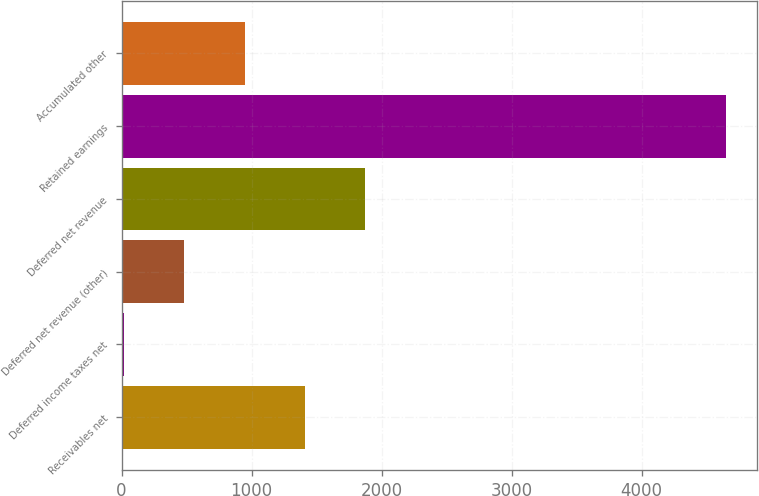Convert chart to OTSL. <chart><loc_0><loc_0><loc_500><loc_500><bar_chart><fcel>Receivables net<fcel>Deferred income taxes net<fcel>Deferred net revenue (other)<fcel>Deferred net revenue<fcel>Retained earnings<fcel>Accumulated other<nl><fcel>1409.6<fcel>20<fcel>483.2<fcel>1872.8<fcel>4652<fcel>946.4<nl></chart> 